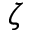Convert formula to latex. <formula><loc_0><loc_0><loc_500><loc_500>\zeta</formula> 